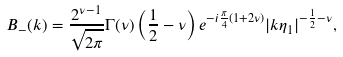Convert formula to latex. <formula><loc_0><loc_0><loc_500><loc_500>B _ { - } ( k ) = \frac { 2 ^ { \nu - 1 } } { \sqrt { 2 \pi } } \Gamma ( \nu ) \left ( \frac { 1 } { 2 } - \nu \right ) e ^ { - i \frac { \pi } { 4 } ( 1 + 2 \nu ) } | k \eta _ { 1 } | ^ { - \frac { 1 } { 2 } - \nu } ,</formula> 